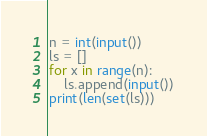Convert code to text. <code><loc_0><loc_0><loc_500><loc_500><_Python_>n = int(input())
ls = []
for x in range(n):
    ls.append(input())
print(len(set(ls)))</code> 